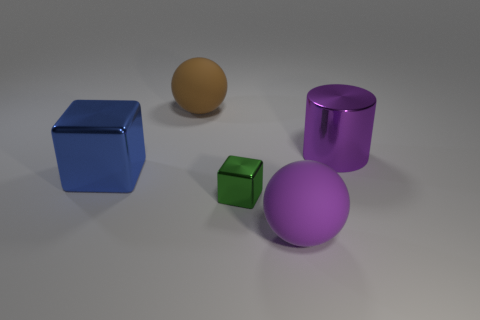Add 2 big matte balls. How many objects exist? 7 Subtract all balls. How many objects are left? 3 Subtract all red metallic objects. Subtract all big blue cubes. How many objects are left? 4 Add 4 green objects. How many green objects are left? 5 Add 4 large cylinders. How many large cylinders exist? 5 Subtract 0 gray spheres. How many objects are left? 5 